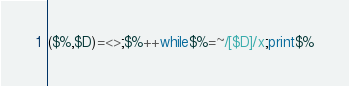Convert code to text. <code><loc_0><loc_0><loc_500><loc_500><_Perl_>($%,$D)=<>;$%++while$%=~/[$D]/x;print$%</code> 